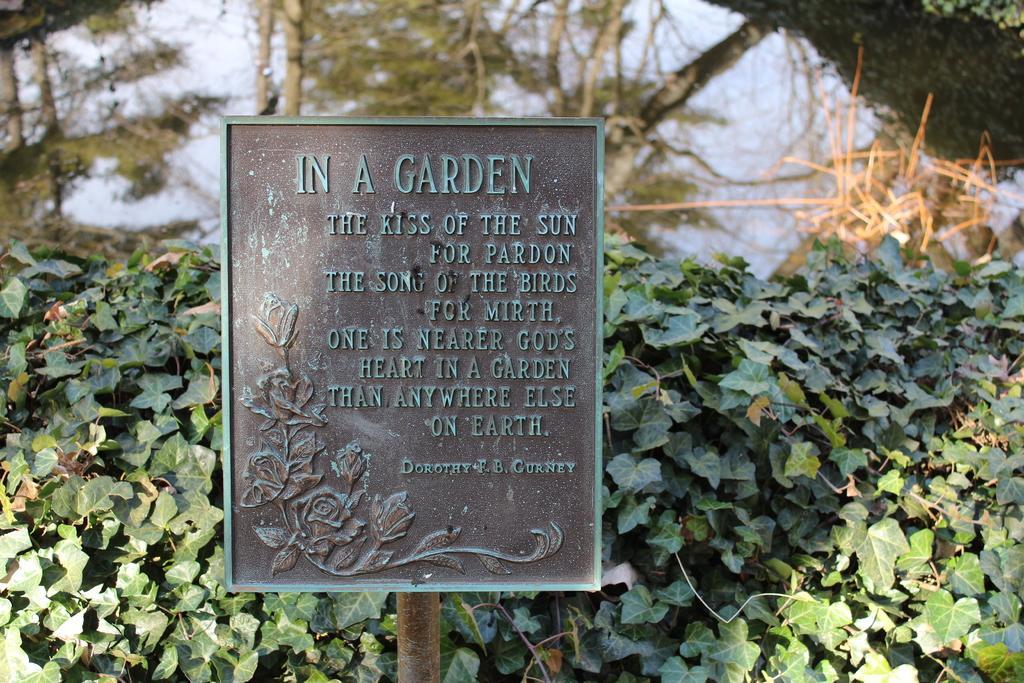How would you summarize this image in a sentence or two? In this image I can see a board attached to the pole, background I can see trees in green color and sky in blue color. 